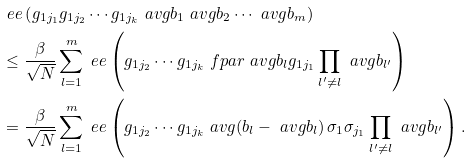Convert formula to latex. <formula><loc_0><loc_0><loc_500><loc_500>& \ e e \left ( g _ { 1 j _ { 1 } } g _ { 1 j _ { 2 } } \cdots g _ { 1 j _ { k } } \ a v g { b _ { 1 } } \ a v g { b _ { 2 } } \cdots \ a v g { b _ { m } } \right ) \\ & \leq \frac { \beta } { \sqrt { N } } \sum _ { l = 1 } ^ { m } \ e e \left ( g _ { 1 j _ { 2 } } \cdots g _ { 1 j _ { k } } \ f p a r { \ a v g { b _ { l } } } { g _ { 1 j _ { 1 } } } \prod _ { l ^ { \prime } \ne l } \ a v g { b _ { l ^ { \prime } } } \right ) \\ & = \frac { \beta } { \sqrt { N } } \sum _ { l = 1 } ^ { m } \ e e \left ( g _ { 1 j _ { 2 } } \cdots g _ { 1 j _ { k } } \ a v g { \left ( b _ { l } - \ a v g { b _ { l } } \right ) \sigma _ { 1 } \sigma _ { j _ { 1 } } } \prod _ { l ^ { \prime } \ne l } \ a v g { b _ { l ^ { \prime } } } \right ) .</formula> 